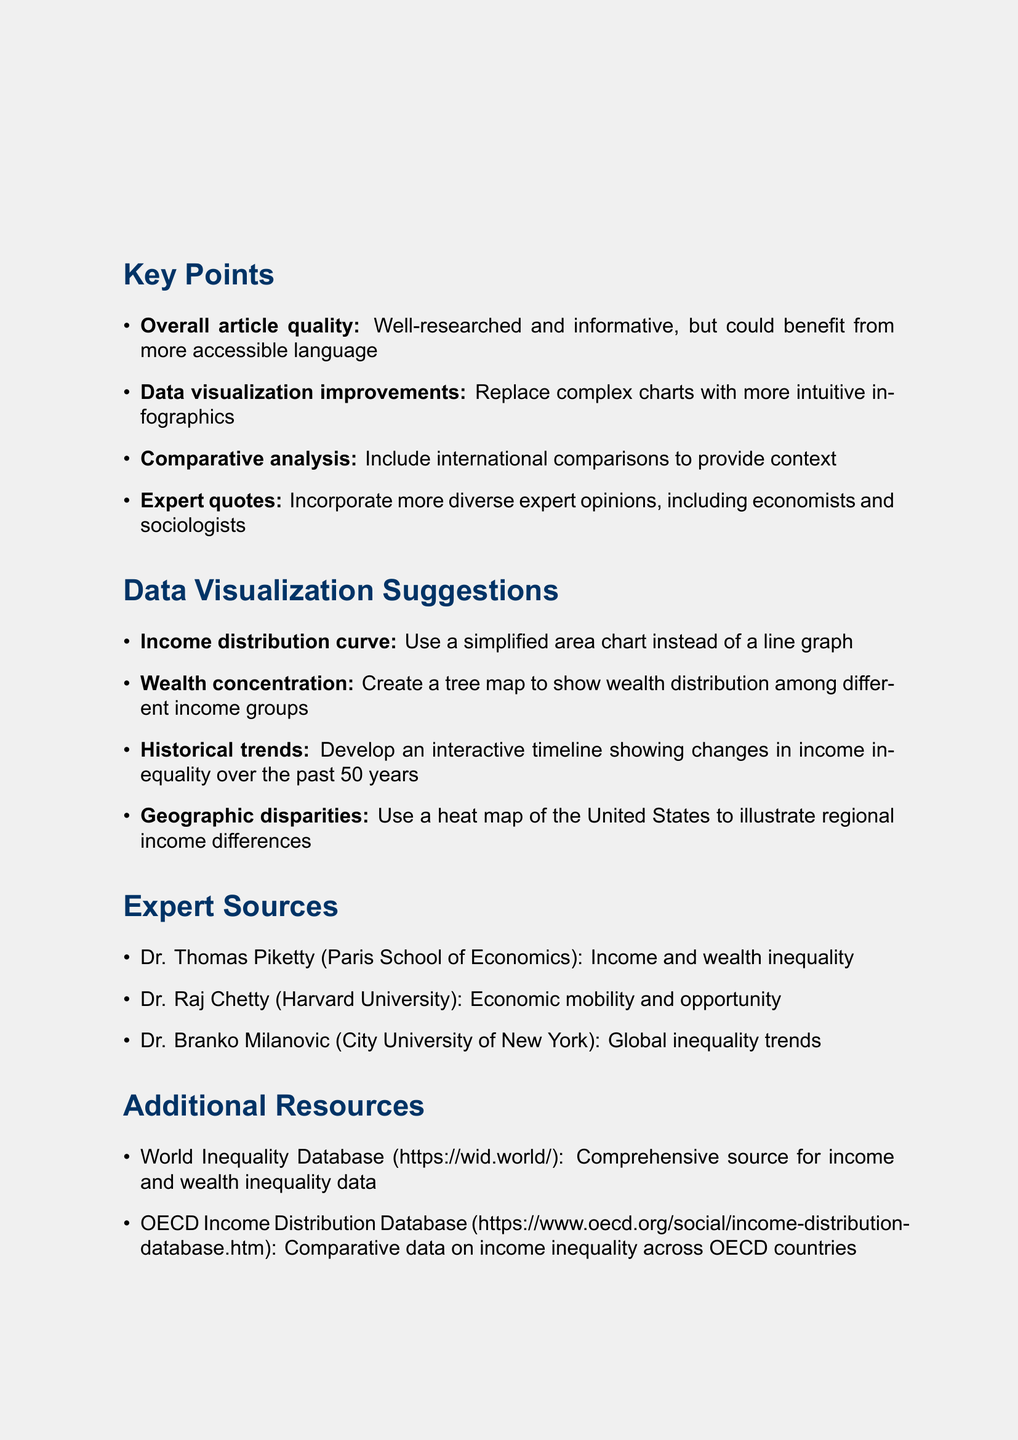what is the title of the memo? The title of the memo is clearly stated at the top of the document.
Answer: Feedback on Income Inequality Feature Article: Improving Data Visualization who is the author of the memo? The author of the memo is identified at the top section of the document.
Answer: Emily Chen how many key points are listed? The number of key points is indicated in the section that presents them.
Answer: Four which visualization suggestion involves a timeline? The relevant suggestion specifically describes the type of visualization that involves historical data.
Answer: Develop an interactive timeline showing changes in income inequality over the past 50 years name one suggested expert source in the memo. The section on expert sources contains several names of experts alongside their affiliations.
Answer: Dr. Thomas Piketty what is one of the conclusions mentioned? The conclusions are summarized in a list, indicating the document's final takeaways.
Answer: Emphasize the importance of making complex economic concepts accessible to the general public how should income distribution be visualized according to the suggestions? The specific suggestion for visualizing income distribution is mentioned clearly.
Answer: Use a simplified area chart instead of a line graph which two databases are referenced as additional resources? The additional resources section lists specific databases with URLs that are relevant to the topic.
Answer: World Inequality Database and OECD Income Distribution Database what is the main focus of the feedback provided in the memo? The overall feedback theme is summarized in key points, mainly addressing improvements.
Answer: Improving data visualization 